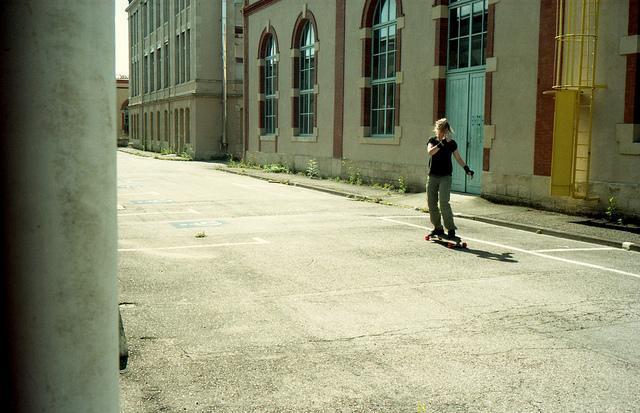How many people are on the boat not at the dock?
Give a very brief answer. 0. 